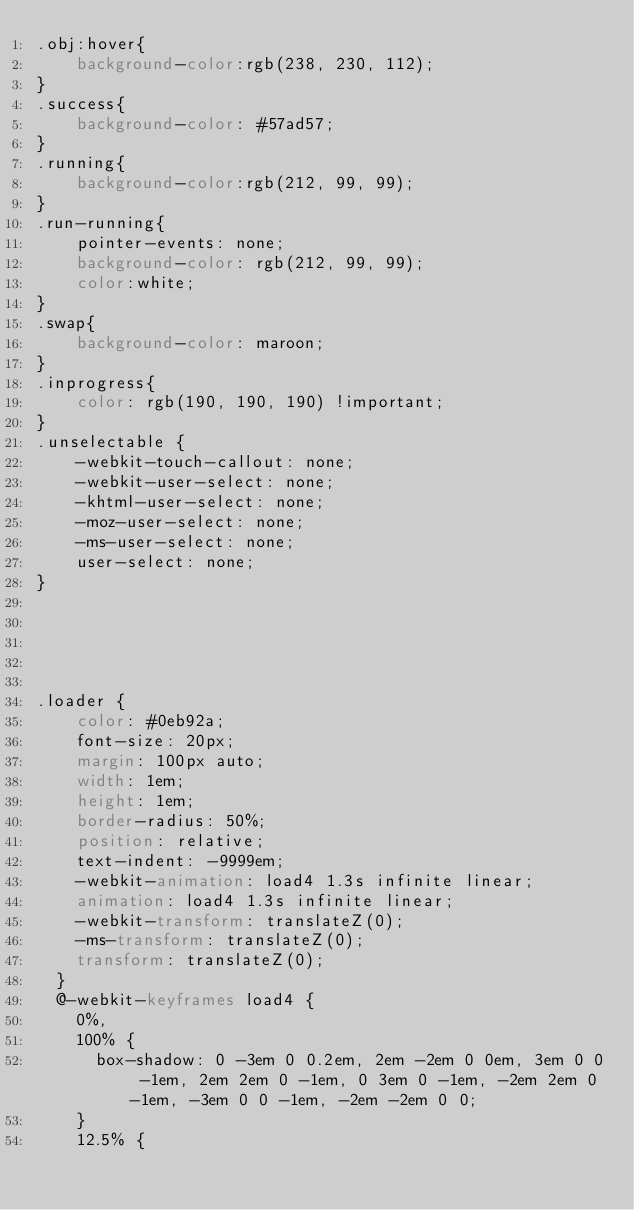<code> <loc_0><loc_0><loc_500><loc_500><_CSS_>.obj:hover{
    background-color:rgb(238, 230, 112);
}
.success{
    background-color: #57ad57;
}
.running{
    background-color:rgb(212, 99, 99);
}
.run-running{
    pointer-events: none;
    background-color: rgb(212, 99, 99);
    color:white;
}
.swap{
    background-color: maroon;
}
.inprogress{
    color: rgb(190, 190, 190) !important;
}
.unselectable {
    -webkit-touch-callout: none;
    -webkit-user-select: none;
    -khtml-user-select: none;
    -moz-user-select: none;
    -ms-user-select: none;
    user-select: none;
}





.loader {
    color: #0eb92a;
    font-size: 20px;
    margin: 100px auto;
    width: 1em;
    height: 1em;
    border-radius: 50%;
    position: relative;
    text-indent: -9999em;
    -webkit-animation: load4 1.3s infinite linear;
    animation: load4 1.3s infinite linear;
    -webkit-transform: translateZ(0);
    -ms-transform: translateZ(0);
    transform: translateZ(0);
  }
  @-webkit-keyframes load4 {
    0%,
    100% {
      box-shadow: 0 -3em 0 0.2em, 2em -2em 0 0em, 3em 0 0 -1em, 2em 2em 0 -1em, 0 3em 0 -1em, -2em 2em 0 -1em, -3em 0 0 -1em, -2em -2em 0 0;
    }
    12.5% {</code> 